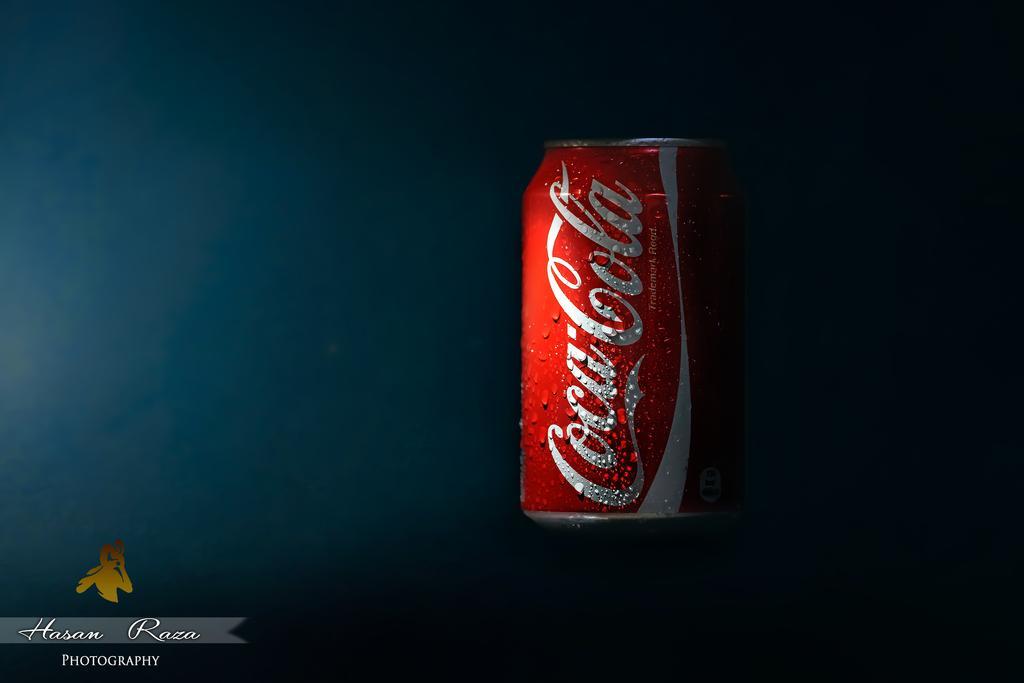Could you give a brief overview of what you see in this image? In the center of the image there is beverage tin. 